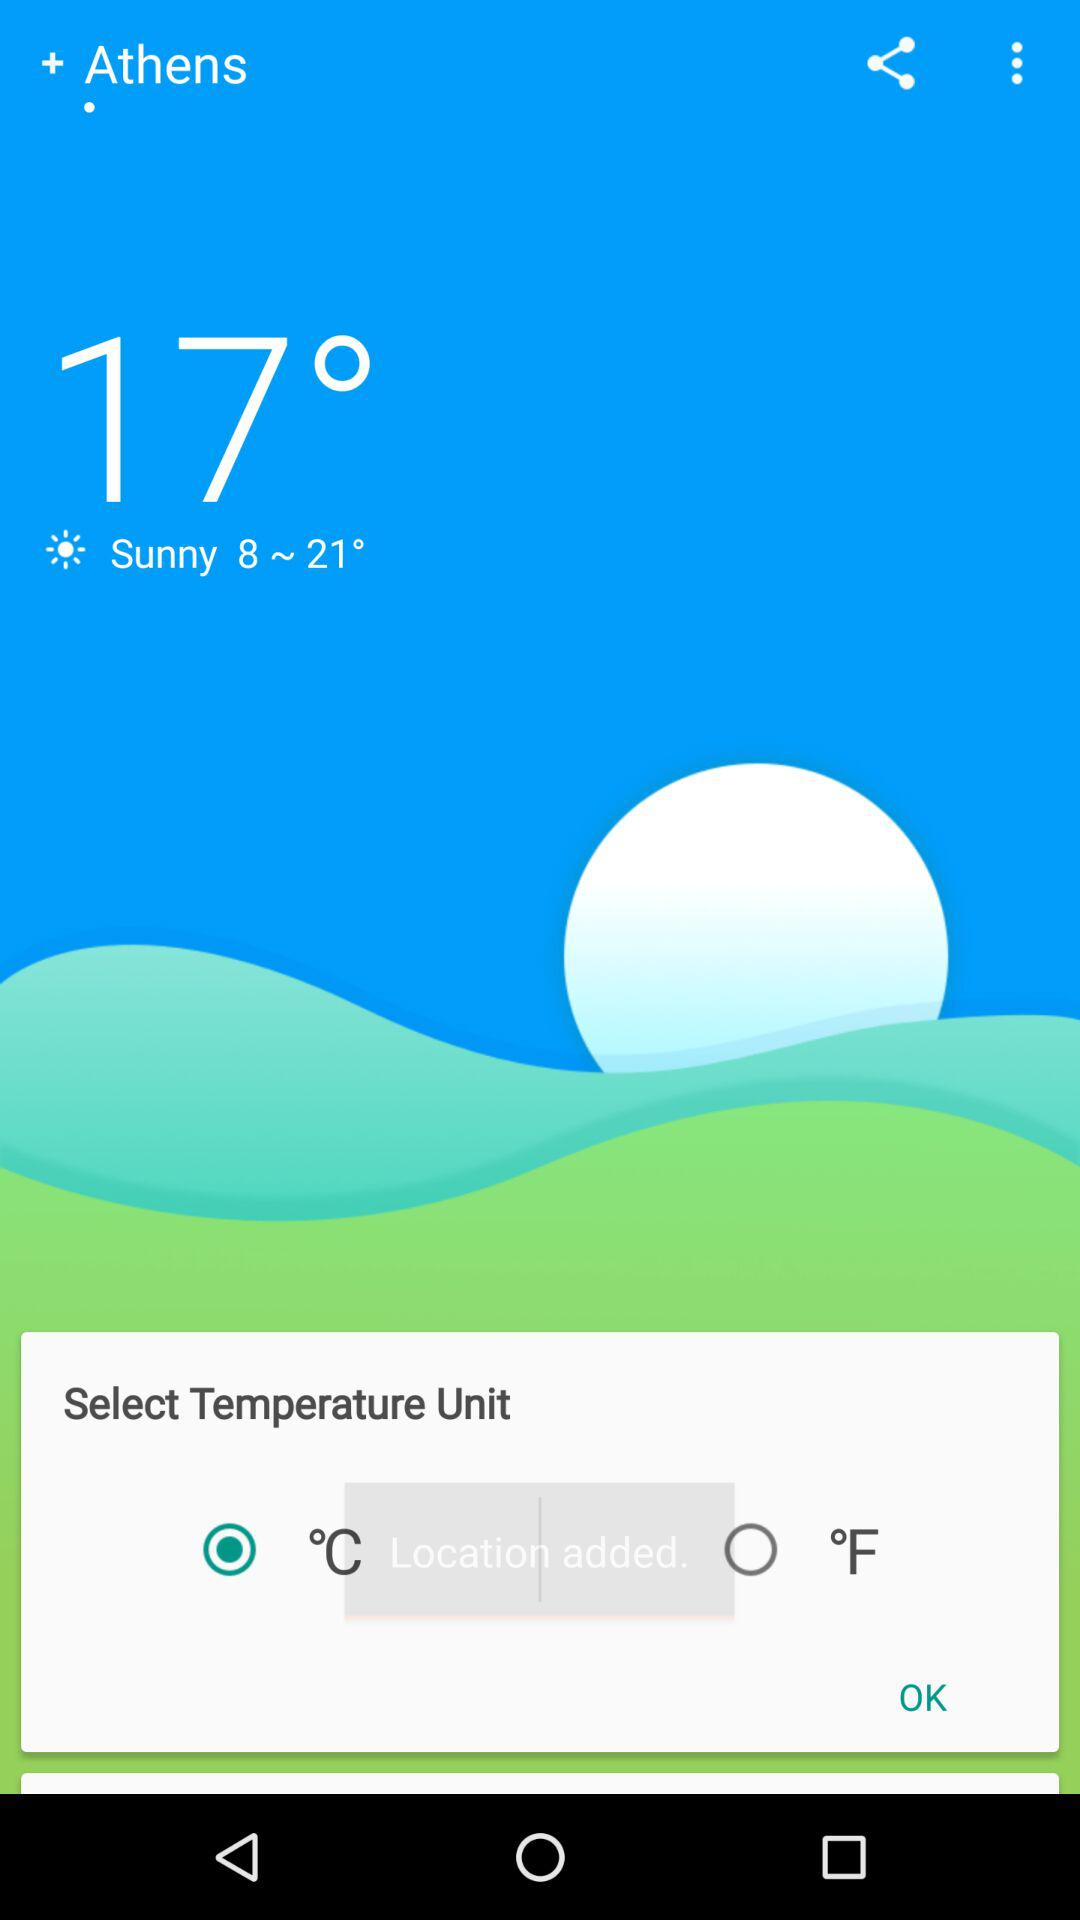How many degrees are there between the lowest and highest possible temperatures for today?
Answer the question using a single word or phrase. 13 